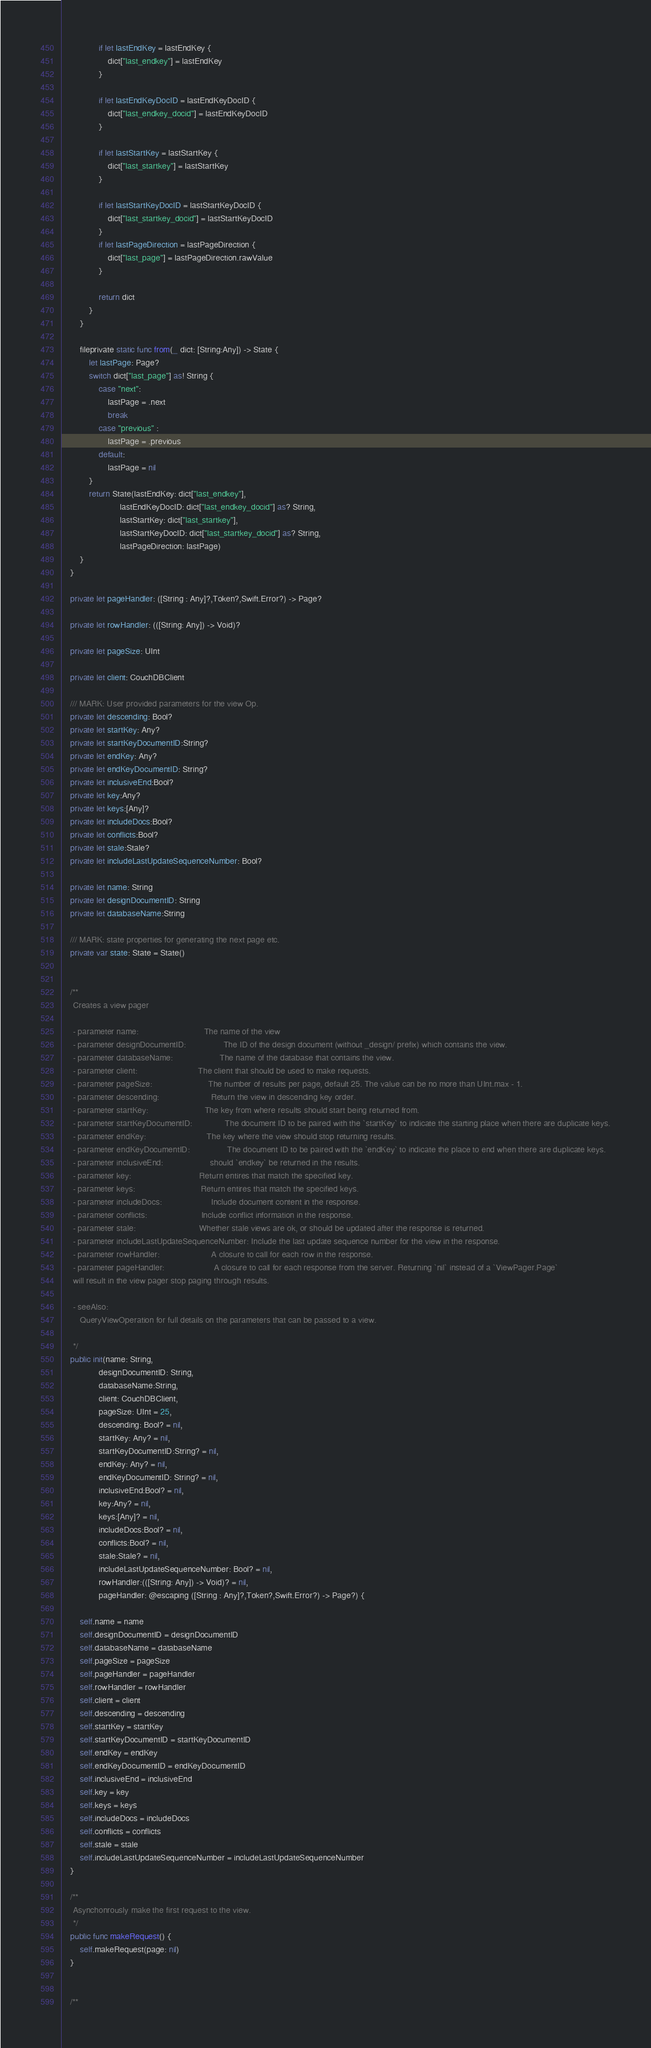Convert code to text. <code><loc_0><loc_0><loc_500><loc_500><_Swift_>                if let lastEndKey = lastEndKey {
                    dict["last_endkey"] = lastEndKey
                }
                
                if let lastEndKeyDocID = lastEndKeyDocID {
                    dict["last_endkey_docid"] = lastEndKeyDocID
                }
                
                if let lastStartKey = lastStartKey {
                    dict["last_startkey"] = lastStartKey
                }
                
                if let lastStartKeyDocID = lastStartKeyDocID {
                    dict["last_startkey_docid"] = lastStartKeyDocID
                }
                if let lastPageDirection = lastPageDirection {
                    dict["last_page"] = lastPageDirection.rawValue
                }
                
                return dict
            }
        }
        
        fileprivate static func from(_ dict: [String:Any]) -> State {
            let lastPage: Page?
            switch dict["last_page"] as! String {
                case "next":
                    lastPage = .next
                    break
                case "previous" :
                    lastPage = .previous
                default:
                    lastPage = nil
            }
            return State(lastEndKey: dict["last_endkey"],
                         lastEndKeyDocID: dict["last_endkey_docid"] as? String,
                         lastStartKey: dict["last_startkey"],
                         lastStartKeyDocID: dict["last_startkey_docid"] as? String,
                         lastPageDirection: lastPage)
        }
    }
    
    private let pageHandler: ([String : Any]?,Token?,Swift.Error?) -> Page?
    
    private let rowHandler: (([String: Any]) -> Void)?
    
    private let pageSize: UInt
    
    private let client: CouchDBClient
    
    /// MARK: User provided parameters for the view Op.
    private let descending: Bool?
    private let startKey: Any?
    private let startKeyDocumentID:String?
    private let endKey: Any?
    private let endKeyDocumentID: String?
    private let inclusiveEnd:Bool?
    private let key:Any?
    private let keys:[Any]?
    private let includeDocs:Bool?
    private let conflicts:Bool?
    private let stale:Stale?
    private let includeLastUpdateSequenceNumber: Bool?
    
    private let name: String
    private let designDocumentID: String
    private let databaseName:String
    
    /// MARK: state properties for generating the next page etc.
    private var state: State = State()
    
    
    /**
     Creates a view pager
    
     - parameter name:                            The name of the view
     - parameter designDocumentID:                The ID of the design document (without _design/ prefix) which contains the view.
     - parameter databaseName:                    The name of the database that contains the view.
     - parameter client:                          The client that should be used to make requests.
     - parameter pageSize:                        The number of results per page, default 25. The value can be no more than UInt.max - 1.
     - parameter descending:                      Return the view in descending key order.
     - parameter startKey:                        The key from where results should start being returned from.
     - parameter startKeyDocumentID:              The document ID to be paired with the `startKey` to indicate the starting place when there are duplicate keys.
     - parameter endKey:                          The key where the view should stop returning results.
     - parameter endKeyDocumentID:                The document ID to be paired with the `endKey` to indicate the place to end when there are duplicate keys.
     - parameter inclusiveEnd:                    should `endkey` be returned in the results.
     - parameter key:                             Return entires that match the specified key.
     - parameter keys:                            Return entires that match the specified keys.
     - parameter includeDocs:                     Include document content in the response.
     - parameter conflicts:                       Include conflict information in the response.
     - parameter stale:                           Whether stale views are ok, or should be updated after the response is returned.
     - parameter includeLastUpdateSequenceNumber: Include the last update sequence number for the view in the response.
     - parameter rowHandler:                      A closure to call for each row in the response.
     - parameter pageHandler:                     A closure to call for each response from the server. Returning `nil` instead of a `ViewPager.Page`
     will result in the view pager stop paging through results.
    
     - seeAlso:
        QueryViewOperation for full details on the parameters that can be passed to a view.
     
     */
    public init(name: String,
                designDocumentID: String,
                databaseName:String,
                client: CouchDBClient,
                pageSize: UInt = 25,
                descending: Bool? = nil,
                startKey: Any? = nil,
                startKeyDocumentID:String? = nil,
                endKey: Any? = nil,
                endKeyDocumentID: String? = nil,
                inclusiveEnd:Bool? = nil,
                key:Any? = nil,
                keys:[Any]? = nil,
                includeDocs:Bool? = nil,
                conflicts:Bool? = nil,
                stale:Stale? = nil,
                includeLastUpdateSequenceNumber: Bool? = nil,
                rowHandler:(([String: Any]) -> Void)? = nil,
                pageHandler: @escaping ([String : Any]?,Token?,Swift.Error?) -> Page?) {
        
        self.name = name
        self.designDocumentID = designDocumentID
        self.databaseName = databaseName
        self.pageSize = pageSize
        self.pageHandler = pageHandler
        self.rowHandler = rowHandler
        self.client = client
        self.descending = descending
        self.startKey = startKey
        self.startKeyDocumentID = startKeyDocumentID
        self.endKey = endKey
        self.endKeyDocumentID = endKeyDocumentID
        self.inclusiveEnd = inclusiveEnd
        self.key = key
        self.keys = keys
        self.includeDocs = includeDocs
        self.conflicts = conflicts
        self.stale = stale
        self.includeLastUpdateSequenceNumber = includeLastUpdateSequenceNumber
    }
    
    /**
     Asynchonrously make the first request to the view.
     */
    public func makeRequest() {
        self.makeRequest(page: nil)
    }
    

    /**</code> 